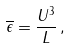<formula> <loc_0><loc_0><loc_500><loc_500>\overline { \epsilon } = \frac { U ^ { 3 } } { L } \, ,</formula> 